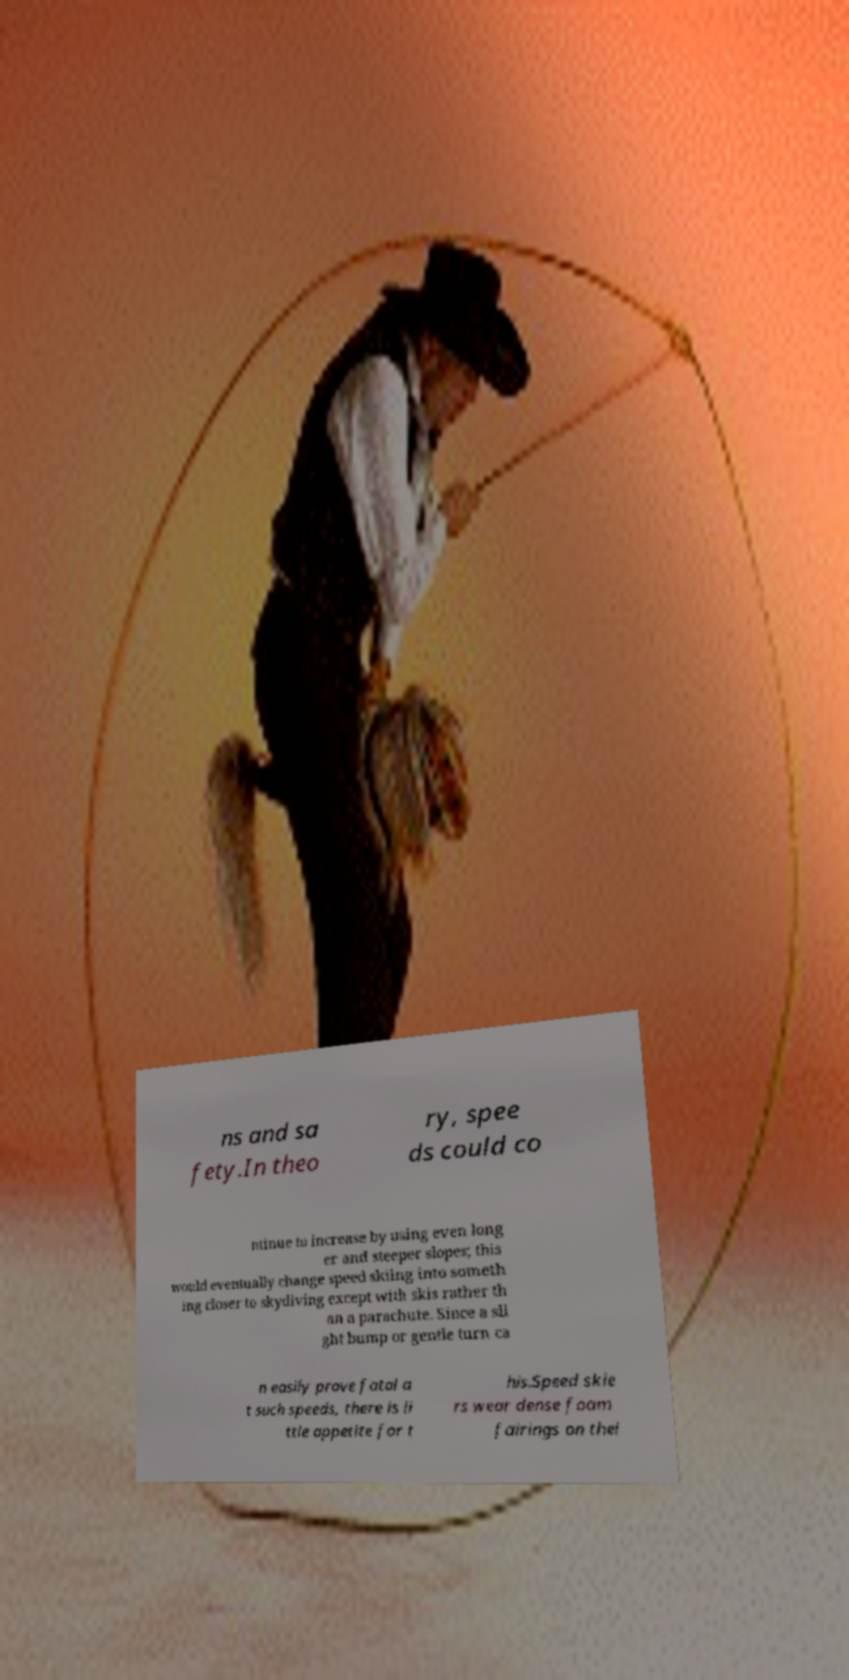Could you assist in decoding the text presented in this image and type it out clearly? ns and sa fety.In theo ry, spee ds could co ntinue to increase by using even long er and steeper slopes; this would eventually change speed skiing into someth ing closer to skydiving except with skis rather th an a parachute. Since a sli ght bump or gentle turn ca n easily prove fatal a t such speeds, there is li ttle appetite for t his.Speed skie rs wear dense foam fairings on thei 